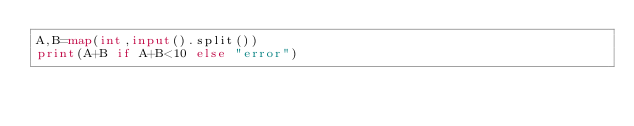<code> <loc_0><loc_0><loc_500><loc_500><_Python_>A,B=map(int,input().split())
print(A+B if A+B<10 else "error")
</code> 